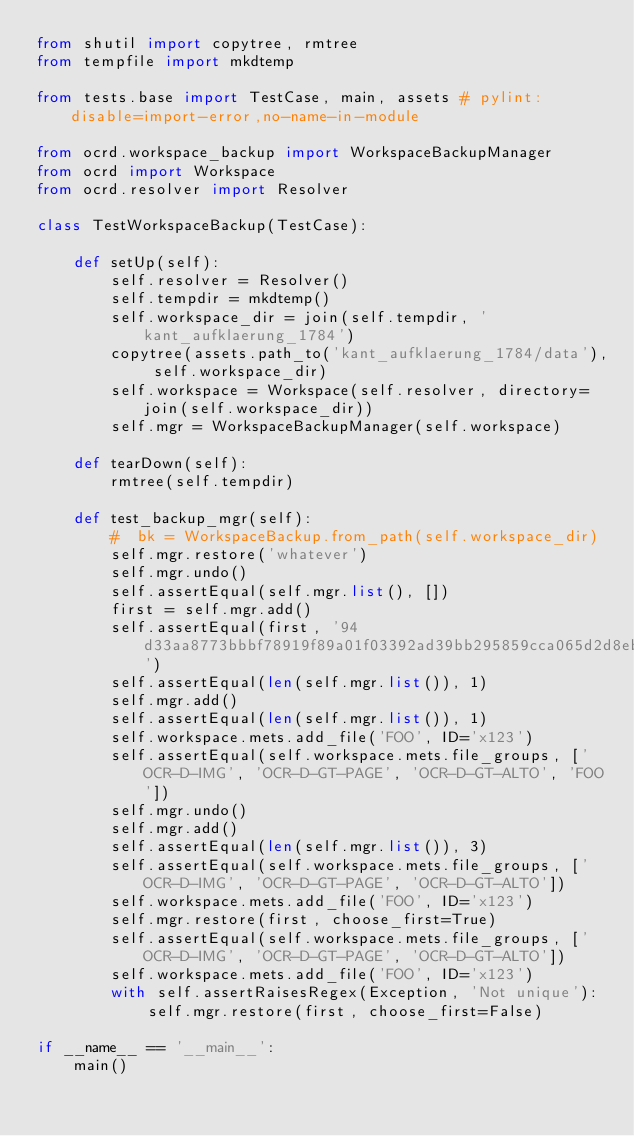<code> <loc_0><loc_0><loc_500><loc_500><_Python_>from shutil import copytree, rmtree
from tempfile import mkdtemp

from tests.base import TestCase, main, assets # pylint: disable=import-error,no-name-in-module

from ocrd.workspace_backup import WorkspaceBackupManager
from ocrd import Workspace
from ocrd.resolver import Resolver

class TestWorkspaceBackup(TestCase):

    def setUp(self):
        self.resolver = Resolver()
        self.tempdir = mkdtemp()
        self.workspace_dir = join(self.tempdir, 'kant_aufklaerung_1784')
        copytree(assets.path_to('kant_aufklaerung_1784/data'), self.workspace_dir)
        self.workspace = Workspace(self.resolver, directory=join(self.workspace_dir))
        self.mgr = WorkspaceBackupManager(self.workspace)

    def tearDown(self):
        rmtree(self.tempdir)

    def test_backup_mgr(self):
        #  bk = WorkspaceBackup.from_path(self.workspace_dir)
        self.mgr.restore('whatever')
        self.mgr.undo()
        self.assertEqual(self.mgr.list(), [])
        first = self.mgr.add()
        self.assertEqual(first, '94d33aa8773bbbf78919f89a01f03392ad39bb295859cca065d2d8eb8a4811e9')
        self.assertEqual(len(self.mgr.list()), 1)
        self.mgr.add()
        self.assertEqual(len(self.mgr.list()), 1)
        self.workspace.mets.add_file('FOO', ID='x123')
        self.assertEqual(self.workspace.mets.file_groups, ['OCR-D-IMG', 'OCR-D-GT-PAGE', 'OCR-D-GT-ALTO', 'FOO'])
        self.mgr.undo()
        self.mgr.add()
        self.assertEqual(len(self.mgr.list()), 3)
        self.assertEqual(self.workspace.mets.file_groups, ['OCR-D-IMG', 'OCR-D-GT-PAGE', 'OCR-D-GT-ALTO'])
        self.workspace.mets.add_file('FOO', ID='x123')
        self.mgr.restore(first, choose_first=True)
        self.assertEqual(self.workspace.mets.file_groups, ['OCR-D-IMG', 'OCR-D-GT-PAGE', 'OCR-D-GT-ALTO'])
        self.workspace.mets.add_file('FOO', ID='x123')
        with self.assertRaisesRegex(Exception, 'Not unique'):
            self.mgr.restore(first, choose_first=False)

if __name__ == '__main__':
    main()
</code> 